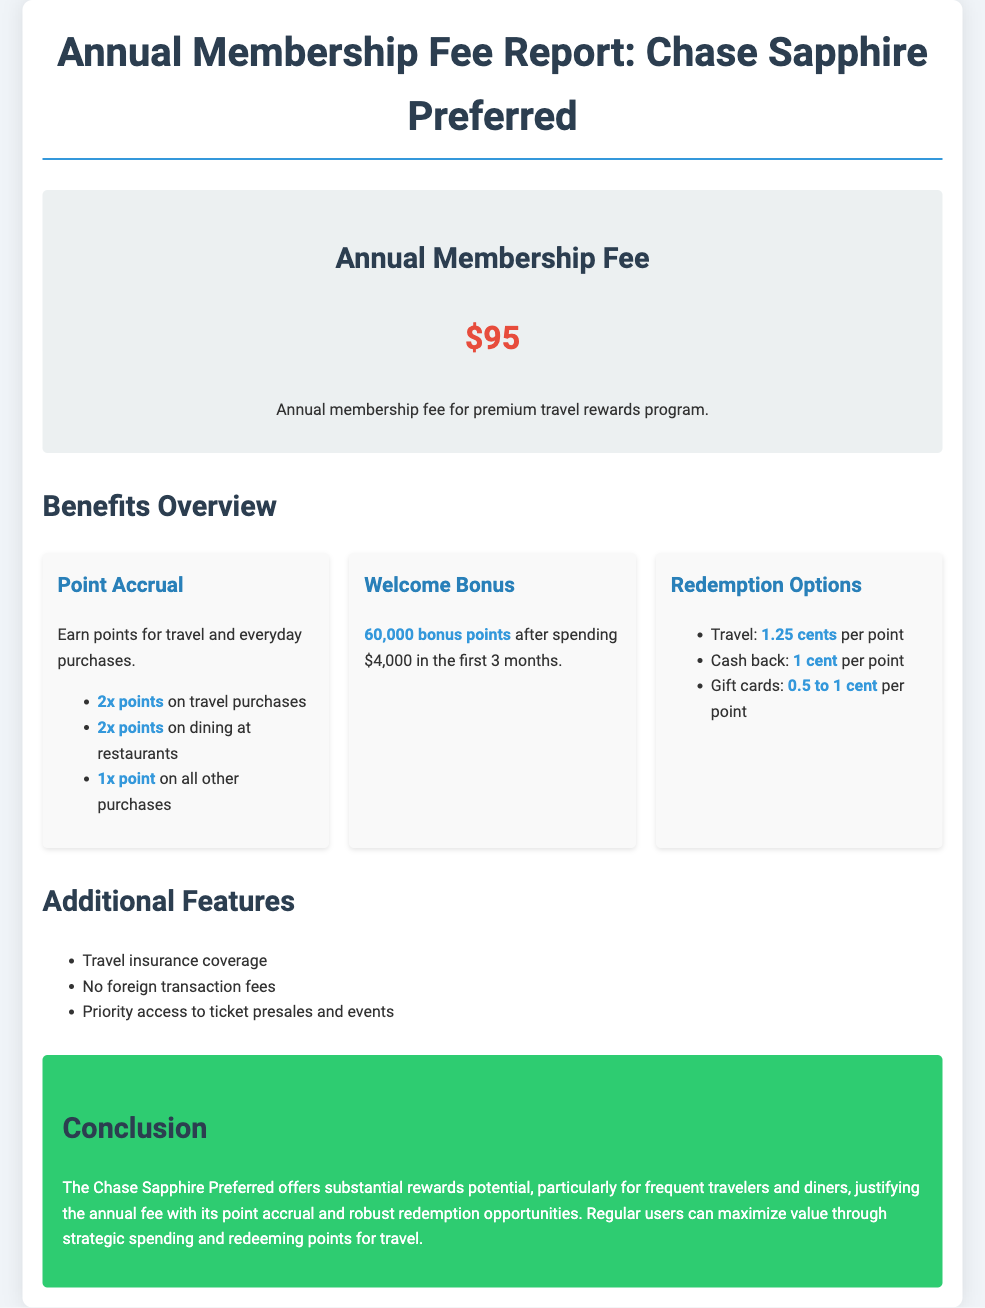What is the annual membership fee? The annual membership fee is listed at the beginning of the report.
Answer: $95 How many bonus points can be earned after the first 3 months? The welcome bonus section outlines the points available after meeting the spending requirement.
Answer: 60,000 bonus points What is the point value for travel redemption? The redemption options detail how much a point is worth when redeemed for travel.
Answer: 1.25 cents per point What is the point accrual rate for dining at restaurants? The point accrual section specifies the points earned on dining purchases.
Answer: 2x points Is there a fee for foreign transactions? The additional features mention whether or not there are costs associated with foreign transactions.
Answer: No foreign transaction fees What main benefits are highlighted for the Chase Sapphire Preferred membership? The benefits overview lists the significant advantages of the membership program.
Answer: Point accrual, Welcome bonus, Redemption options What type of coverage is provided with the membership? The additional features section states a specific type of coverage associated with the membership.
Answer: Travel insurance coverage What spending amount is required to earn the welcome bonus? The welcome bonus section specifies the spending requirement needed to qualify for the bonus.
Answer: $4,000 